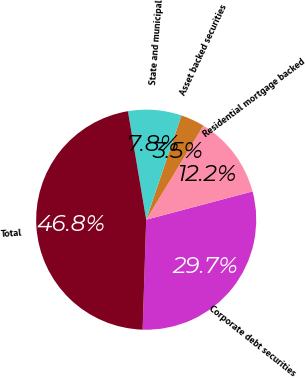Convert chart. <chart><loc_0><loc_0><loc_500><loc_500><pie_chart><fcel>Corporate debt securities<fcel>Residential mortgage backed<fcel>Asset backed securities<fcel>State and municipal<fcel>Total<nl><fcel>29.65%<fcel>12.17%<fcel>3.51%<fcel>7.84%<fcel>46.82%<nl></chart> 